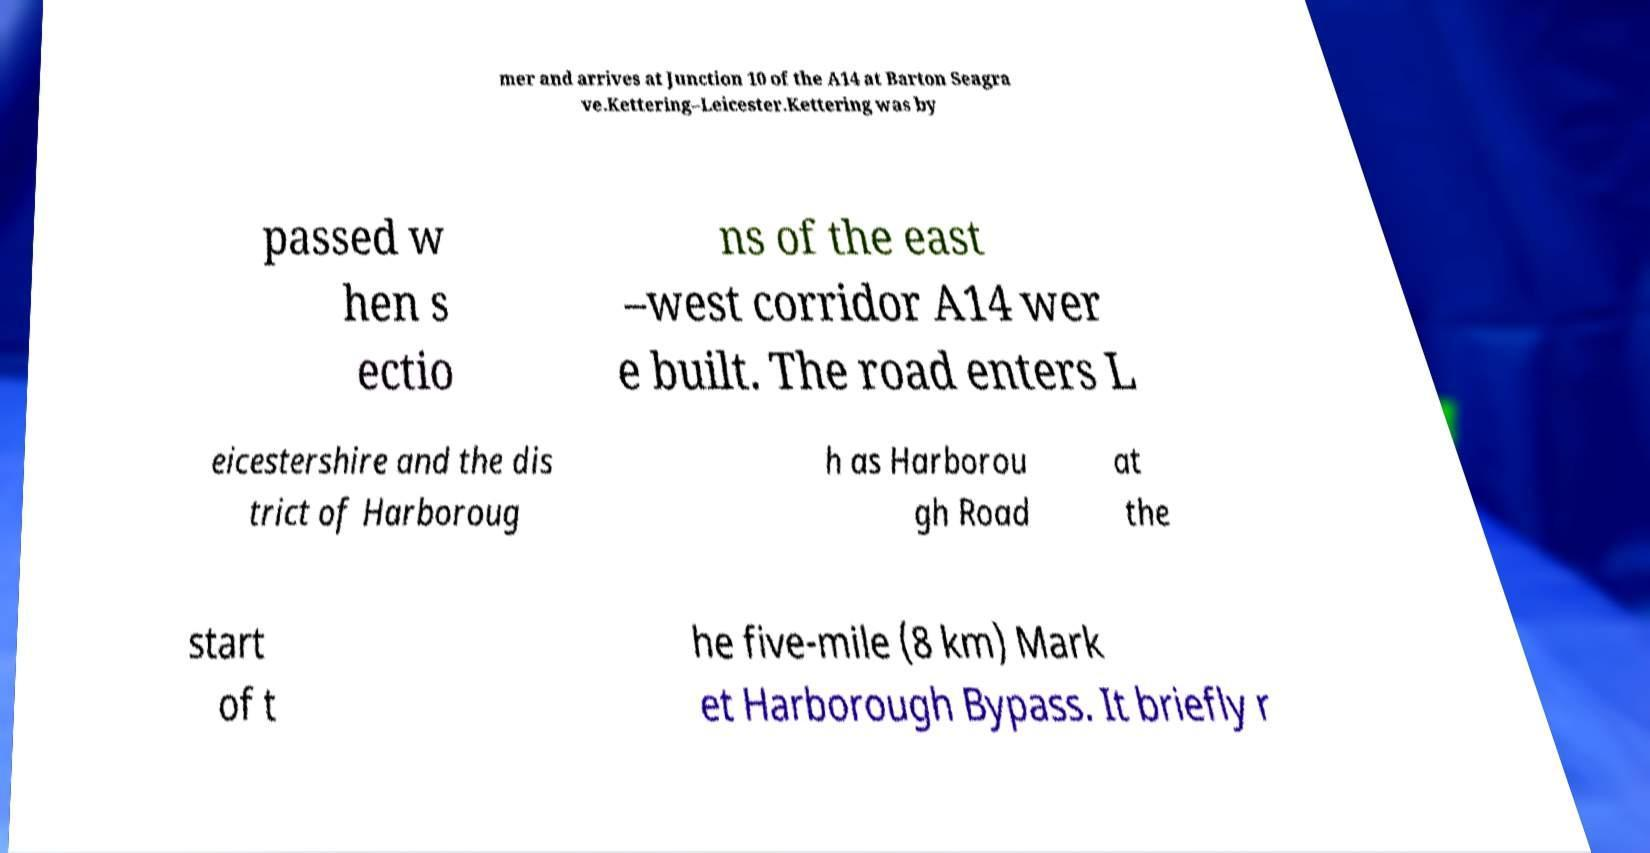I need the written content from this picture converted into text. Can you do that? mer and arrives at Junction 10 of the A14 at Barton Seagra ve.Kettering–Leicester.Kettering was by passed w hen s ectio ns of the east –west corridor A14 wer e built. The road enters L eicestershire and the dis trict of Harboroug h as Harborou gh Road at the start of t he five-mile (8 km) Mark et Harborough Bypass. It briefly r 